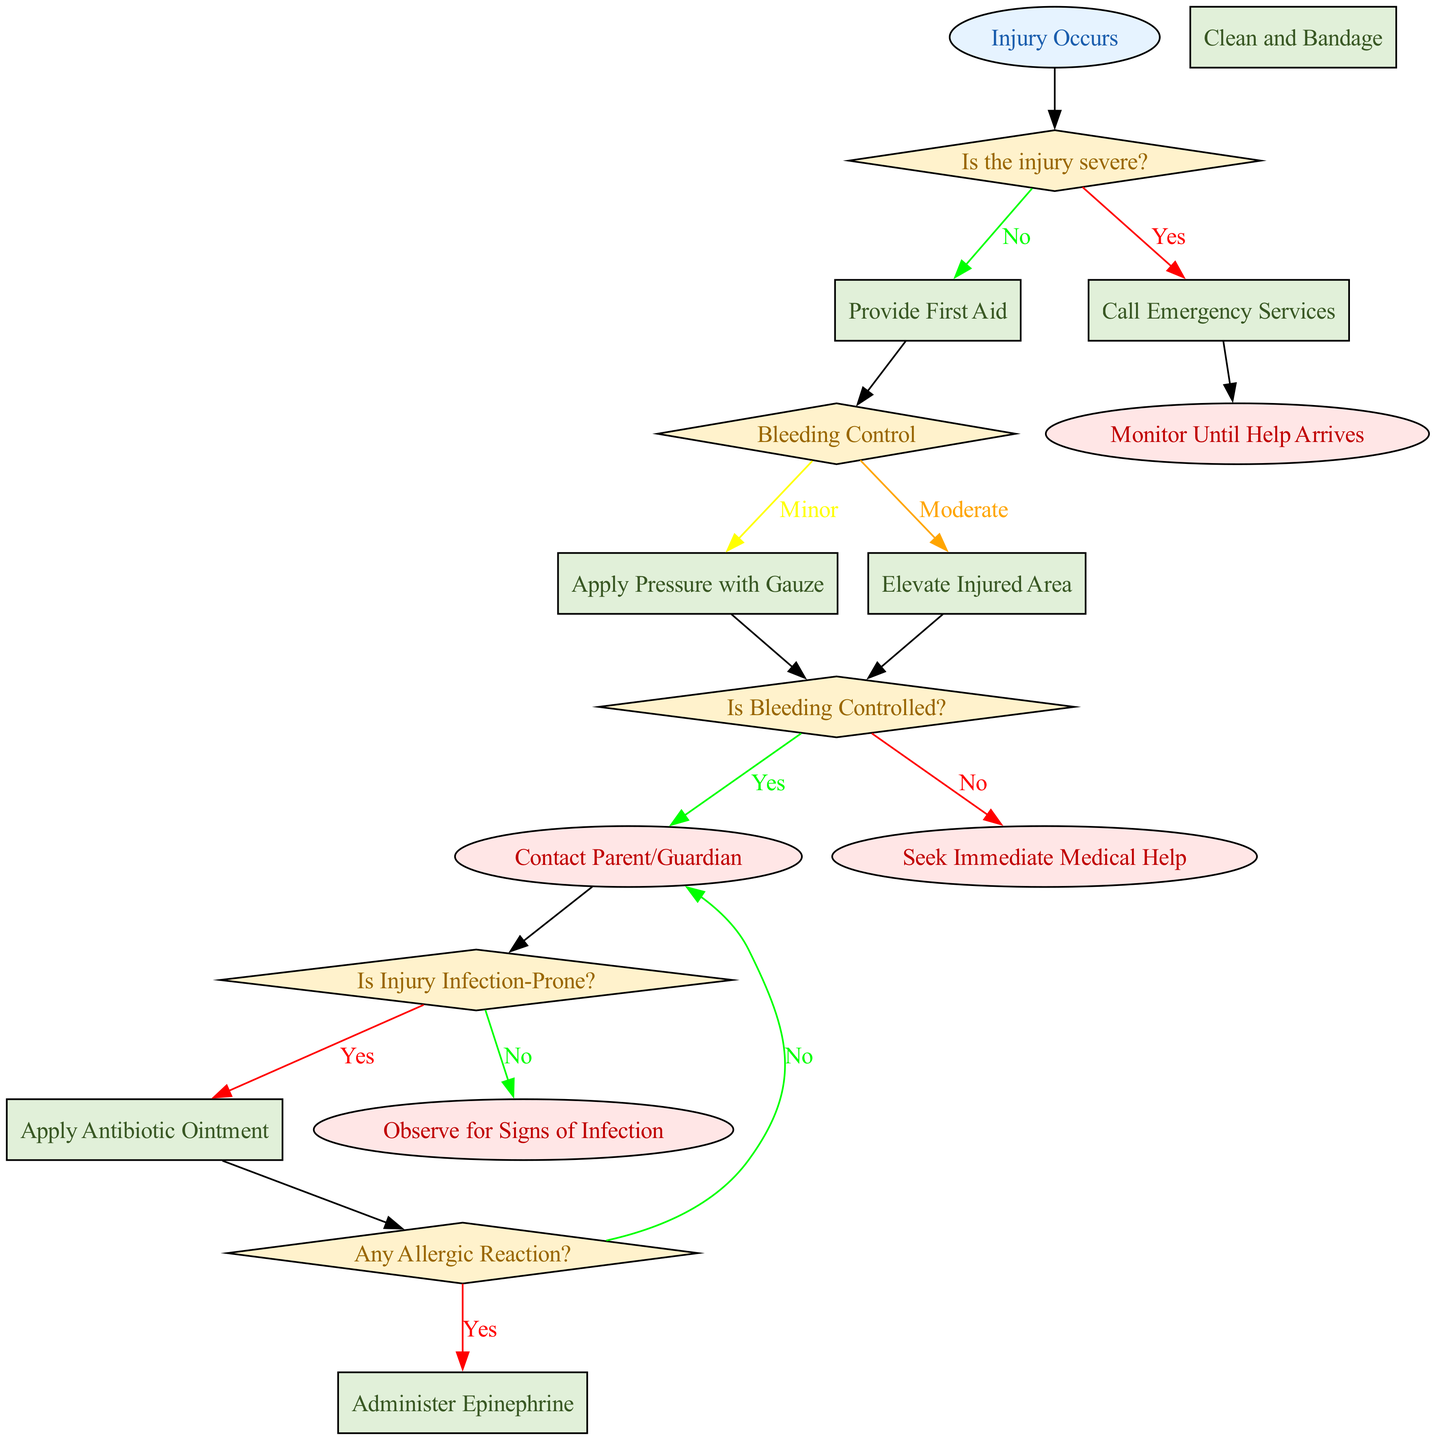What is the starting point of the flowchart? The first node in the flowchart is labeled "Injury Occurs," indicating the starting point of the response process when a student is injured.
Answer: Injury Occurs How many decision nodes are present in the flowchart? There are four decision nodes in the flowchart: "Is the injury severe?", "Bleeding Control", "Is Bleeding Controlled?", and "Is Injury Infection-Prone?"
Answer: 4 What action is taken if the injury is not severe? If the injury is not severe, the flow goes to the process node labeled "Provide First Aid," which indicates the next course of action for the responder.
Answer: Provide First Aid What happens if bleeding is controlled? If bleeding is controlled (from the decision node "Is Bleeding Controlled?"), the flowchart directs to "Contact Parent/Guardian," indicating that the parent or guardian should be notified about the situation.
Answer: Contact Parent/Guardian What is the next step after applying pressure with gauze? After applying pressure with gauze, the next step indicated is the decision node "Is Bleeding Controlled?", where the responder assesses the effectiveness of their actions.
Answer: Is Bleeding Controlled? What is the output if there is an allergic reaction? If there is an allergic reaction as determined in the flowchart, the responder will take the action labeled "Administer Epinephrine," which is critical in cases of severe allergic reactions.
Answer: Administer Epinephrine What are the ending points of this flowchart? The flowchart has three end points: "Contact Parent/Guardian", "Monitor Until Help Arrives", and "Seek Immediate Medical Help", which signify various outcomes based on the decisions made during the process.
Answer: Contact Parent/Guardian, Monitor Until Help Arrives, Seek Immediate Medical Help What color represents the decision nodes in the flowchart? The decision nodes are filled with a light yellow color as indicated in the node styles section of the diagram.
Answer: Yellow What should be done if the injury is infection-prone? If the injury is identified as infection-prone, the flow directs to "Apply Antibiotic Ointment" which is a preventive measure against infections.
Answer: Apply Antibiotic Ointment 